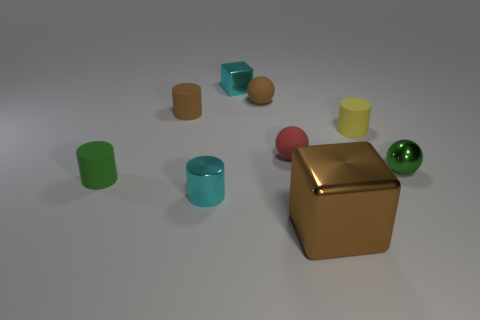Subtract all tiny metal spheres. How many spheres are left? 2 Subtract all green cylinders. How many cylinders are left? 3 Subtract 3 cylinders. How many cylinders are left? 1 Subtract all balls. How many objects are left? 6 Subtract 0 cyan balls. How many objects are left? 9 Subtract all gray balls. Subtract all red cubes. How many balls are left? 3 Subtract all red cubes. How many cyan cylinders are left? 1 Subtract all tiny cyan shiny cylinders. Subtract all brown metal blocks. How many objects are left? 7 Add 8 shiny balls. How many shiny balls are left? 9 Add 1 tiny brown matte balls. How many tiny brown matte balls exist? 2 